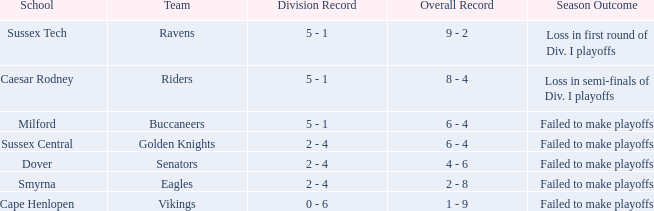What is the total performance history for the milford school? 6 - 4. 